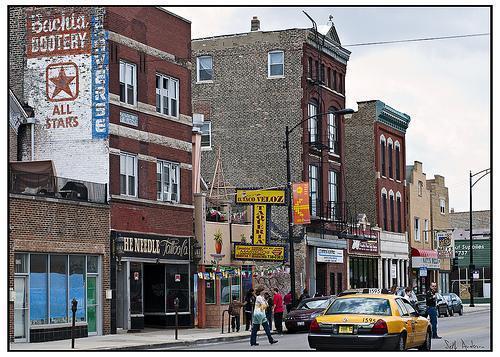How many cars are in the middle of the street?
Give a very brief answer. 1. How many stories is the tallest building in the photo?
Give a very brief answer. 4. How many red chairs are there?
Give a very brief answer. 0. 